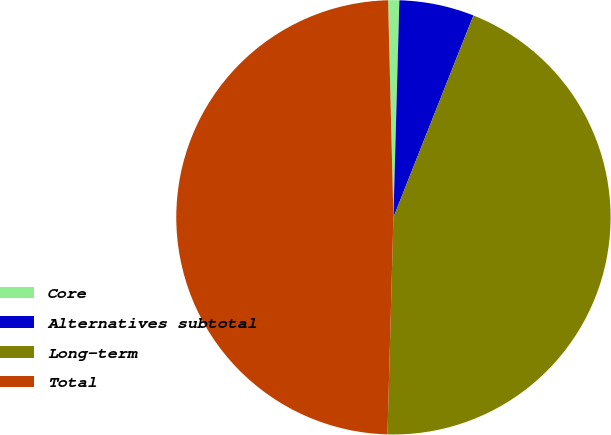Convert chart to OTSL. <chart><loc_0><loc_0><loc_500><loc_500><pie_chart><fcel>Core<fcel>Alternatives subtotal<fcel>Long-term<fcel>Total<nl><fcel>0.83%<fcel>5.57%<fcel>44.43%<fcel>49.17%<nl></chart> 